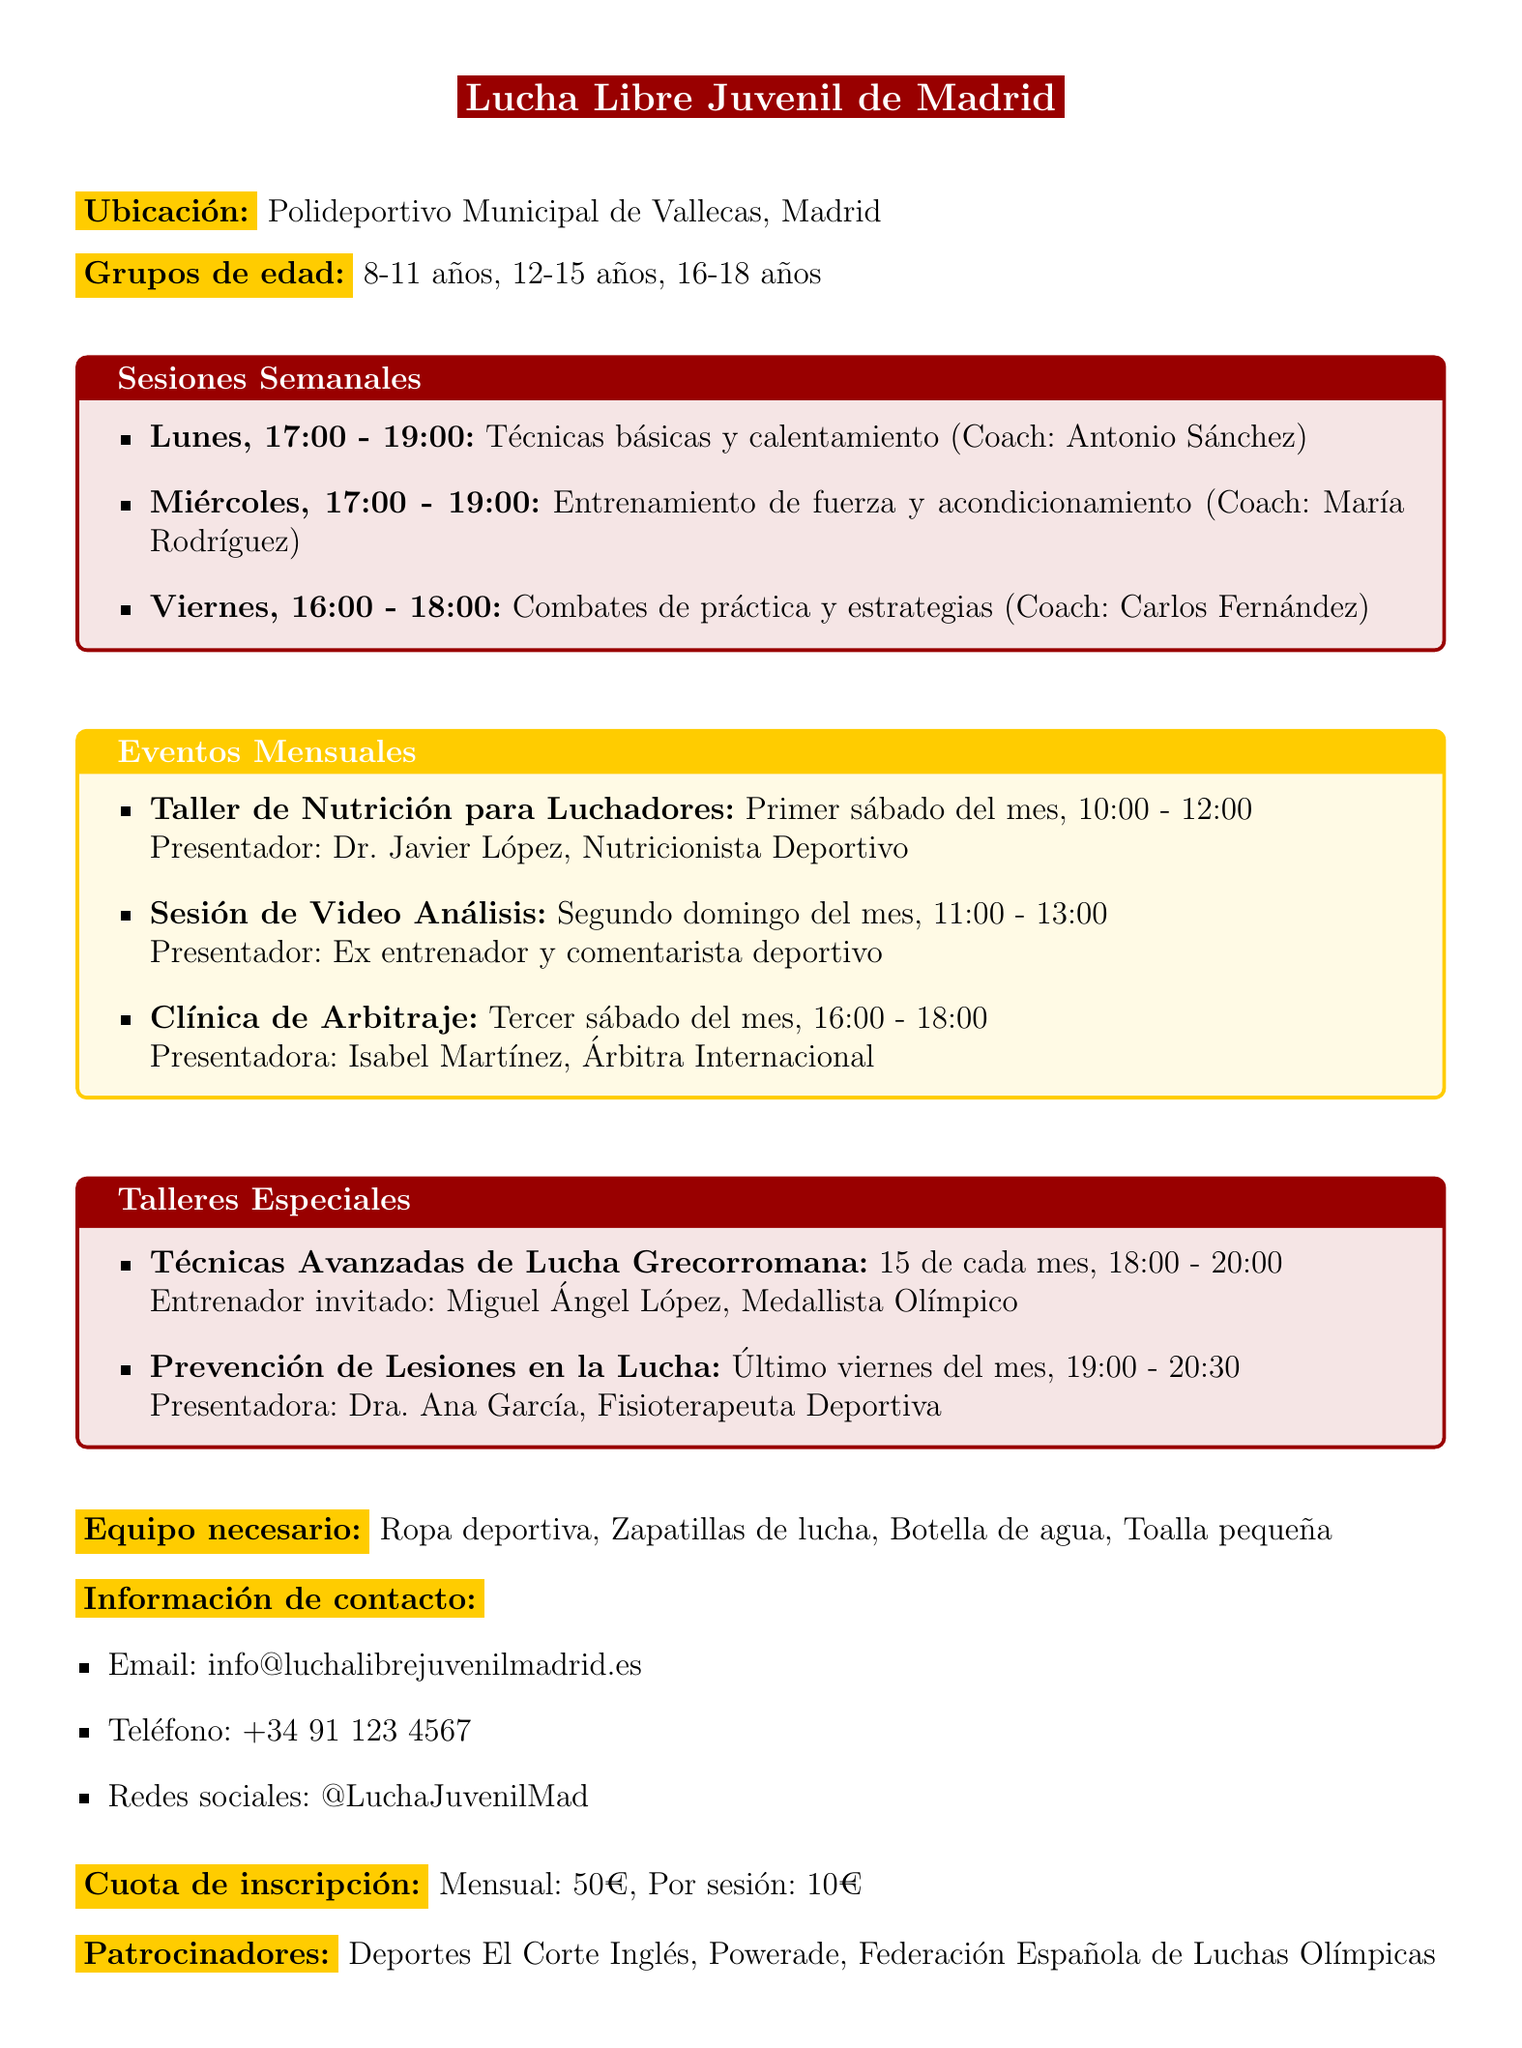What is the clinic name? The clinic name is mentioned at the top of the document as "Lucha Libre Juvenil de Madrid."
Answer: Lucha Libre Juvenil de Madrid Where is the clinic located? The document specifies the location as "Polideportivo Municipal de Vallecas, Madrid."
Answer: Polideportivo Municipal de Vallecas, Madrid Who is the coach for the Monday session? The document lists "Antonio Sánchez" as the coach for the Monday session focused on basic techniques and warming up.
Answer: Antonio Sánchez What is the age group for the second workshop? The second workshop is scheduled for the age group "12-15 años," as indicated in the document.
Answer: 12-15 años When is the session on injury prevention scheduled? The document states that the injury prevention session occurs on the "Último viernes del mes."
Answer: Último viernes del mes Who presents the nutrition workshop? The document notes that the nutrition workshop is presented by "Dr. Javier López, Nutricionista Deportivo."
Answer: Dr. Javier López, Nutricionista Deportivo What equipment is needed for the clinic? The document lists necessary equipment as "Ropa deportiva, Zapatillas de lucha, Botella de agua, Toalla pequeña."
Answer: Ropa deportiva, Zapatillas de lucha, Botella de agua, Toalla pequeña What is the monthly registration fee? The document specifies that the monthly registration fee is "50€."
Answer: 50€ How often are the strength training sessions held? The document indicates that strength training sessions occur once a week on Wednesdays.
Answer: Una vez a la semana Who is the guest coach for advanced Greco-Roman techniques? The document states that "Miguel Ángel López, Medallista Olímpico" is the guest coach for this session.
Answer: Miguel Ángel López, Medallista Olímpico 